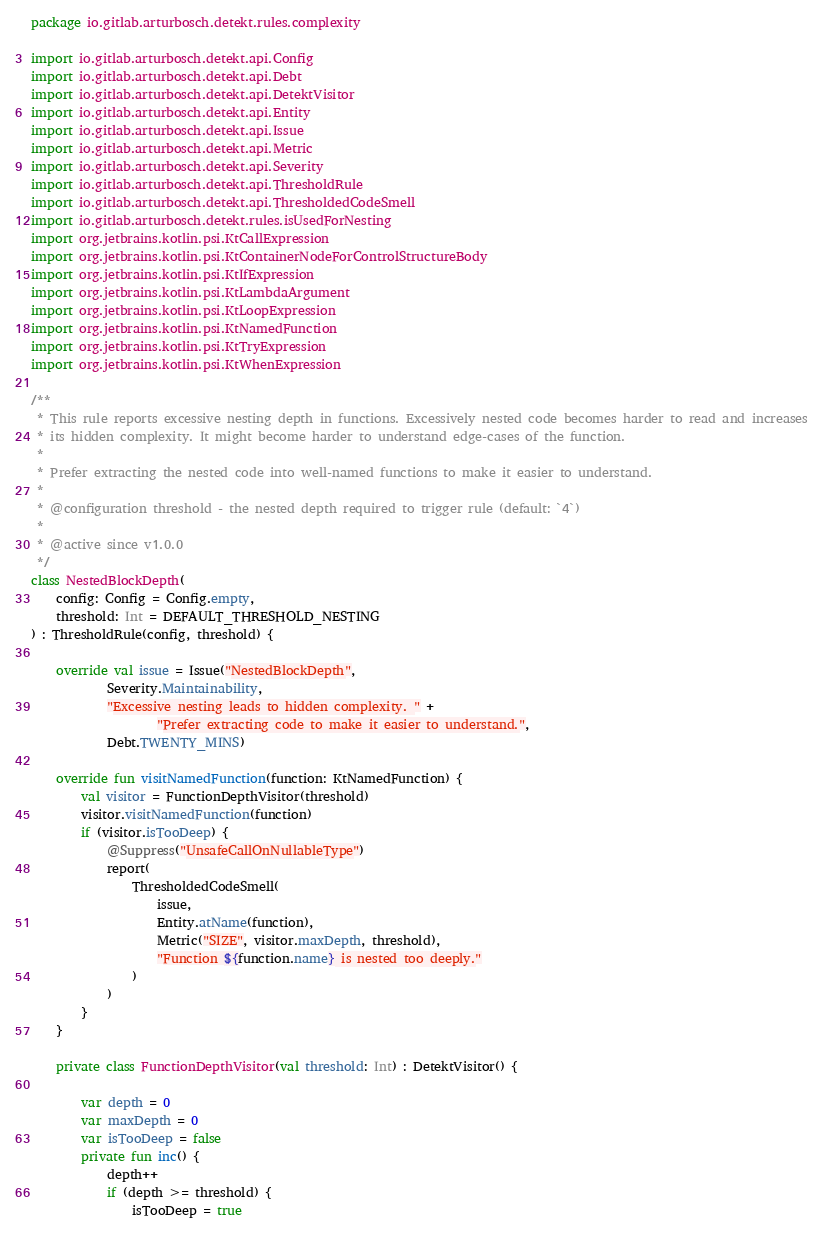Convert code to text. <code><loc_0><loc_0><loc_500><loc_500><_Kotlin_>package io.gitlab.arturbosch.detekt.rules.complexity

import io.gitlab.arturbosch.detekt.api.Config
import io.gitlab.arturbosch.detekt.api.Debt
import io.gitlab.arturbosch.detekt.api.DetektVisitor
import io.gitlab.arturbosch.detekt.api.Entity
import io.gitlab.arturbosch.detekt.api.Issue
import io.gitlab.arturbosch.detekt.api.Metric
import io.gitlab.arturbosch.detekt.api.Severity
import io.gitlab.arturbosch.detekt.api.ThresholdRule
import io.gitlab.arturbosch.detekt.api.ThresholdedCodeSmell
import io.gitlab.arturbosch.detekt.rules.isUsedForNesting
import org.jetbrains.kotlin.psi.KtCallExpression
import org.jetbrains.kotlin.psi.KtContainerNodeForControlStructureBody
import org.jetbrains.kotlin.psi.KtIfExpression
import org.jetbrains.kotlin.psi.KtLambdaArgument
import org.jetbrains.kotlin.psi.KtLoopExpression
import org.jetbrains.kotlin.psi.KtNamedFunction
import org.jetbrains.kotlin.psi.KtTryExpression
import org.jetbrains.kotlin.psi.KtWhenExpression

/**
 * This rule reports excessive nesting depth in functions. Excessively nested code becomes harder to read and increases
 * its hidden complexity. It might become harder to understand edge-cases of the function.
 *
 * Prefer extracting the nested code into well-named functions to make it easier to understand.
 *
 * @configuration threshold - the nested depth required to trigger rule (default: `4`)
 *
 * @active since v1.0.0
 */
class NestedBlockDepth(
    config: Config = Config.empty,
    threshold: Int = DEFAULT_THRESHOLD_NESTING
) : ThresholdRule(config, threshold) {

    override val issue = Issue("NestedBlockDepth",
            Severity.Maintainability,
            "Excessive nesting leads to hidden complexity. " +
                    "Prefer extracting code to make it easier to understand.",
            Debt.TWENTY_MINS)

    override fun visitNamedFunction(function: KtNamedFunction) {
        val visitor = FunctionDepthVisitor(threshold)
        visitor.visitNamedFunction(function)
        if (visitor.isTooDeep) {
            @Suppress("UnsafeCallOnNullableType")
            report(
                ThresholdedCodeSmell(
                    issue,
                    Entity.atName(function),
                    Metric("SIZE", visitor.maxDepth, threshold),
                    "Function ${function.name} is nested too deeply."
                )
            )
        }
    }

    private class FunctionDepthVisitor(val threshold: Int) : DetektVisitor() {

        var depth = 0
        var maxDepth = 0
        var isTooDeep = false
        private fun inc() {
            depth++
            if (depth >= threshold) {
                isTooDeep = true</code> 